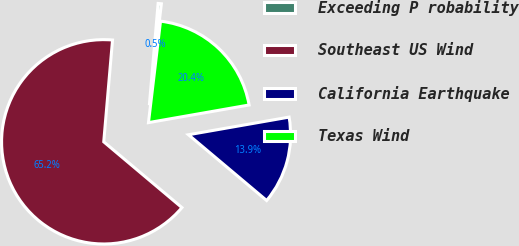<chart> <loc_0><loc_0><loc_500><loc_500><pie_chart><fcel>Exceeding P robability<fcel>Southeast US Wind<fcel>California Earthquake<fcel>Texas Wind<nl><fcel>0.51%<fcel>65.24%<fcel>13.89%<fcel>20.36%<nl></chart> 